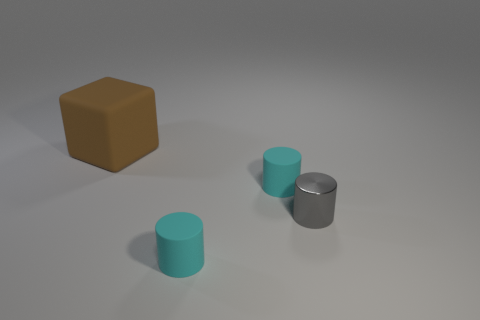Add 4 rubber things. How many objects exist? 8 Subtract all cylinders. How many objects are left? 1 Add 4 gray metallic cylinders. How many gray metallic cylinders are left? 5 Add 2 gray shiny cylinders. How many gray shiny cylinders exist? 3 Subtract 0 gray cubes. How many objects are left? 4 Subtract all large purple shiny spheres. Subtract all gray cylinders. How many objects are left? 3 